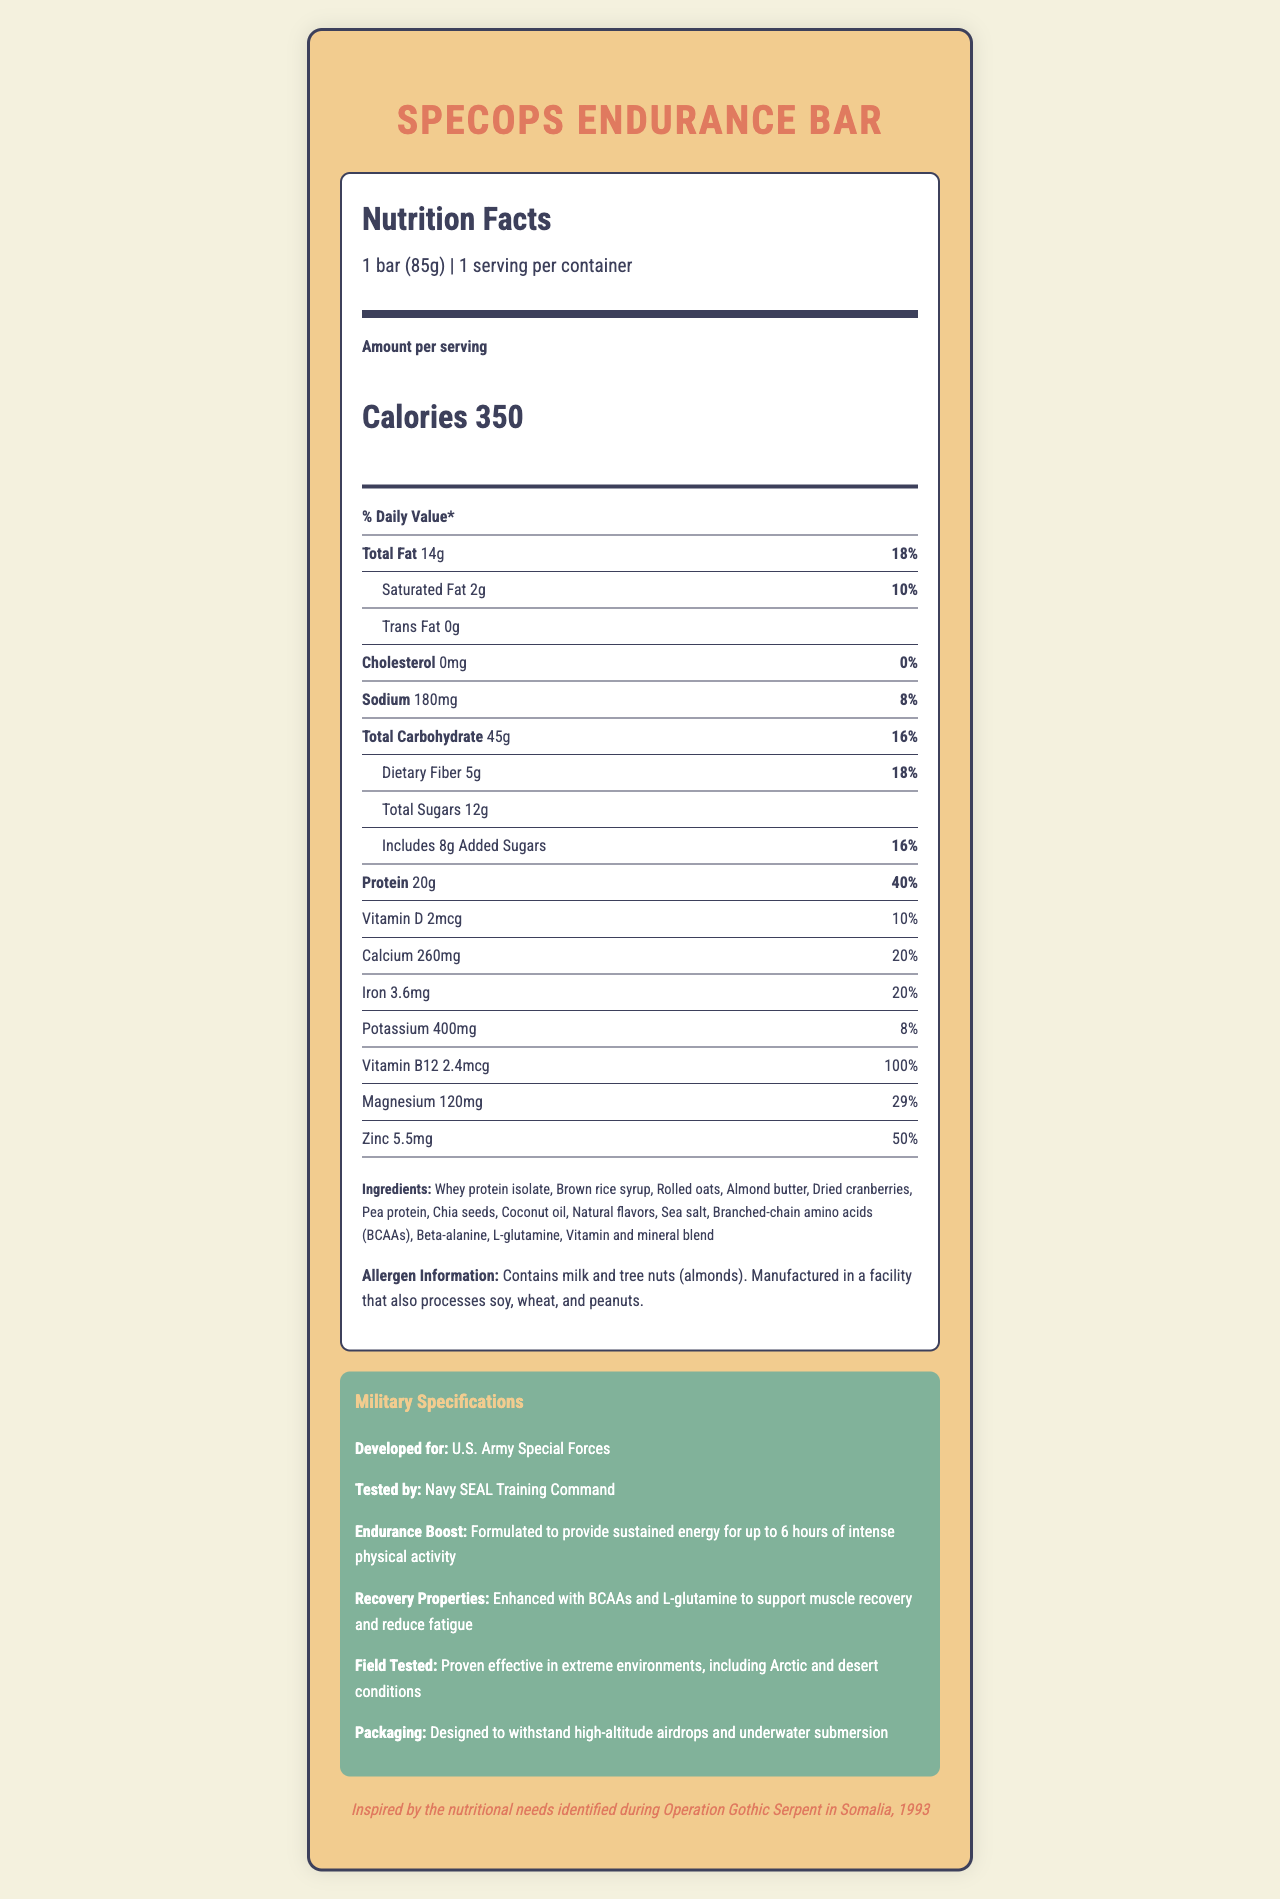what is the serving size? The serving size is specified as "1 bar (85g)" in the nutrition facts section.
Answer: 1 bar (85g) how many calories are there per serving? The document states that there are 350 calories per serving.
Answer: 350 how much protein does the SpecOps Endurance Bar contain per serving? The nutrition facts label lists 20g of protein per serving.
Answer: 20g what is the percentage daily value of magnesium? According to the document, magnesium has a daily value of 29%.
Answer: 29% which allergen is contained in the bar? The allergen information in the document lists milk and tree nuts (almonds) as allergens.
Answer: Milk and tree nuts (almonds) what is the main source of protein in the SpecOps Endurance Bar? The ingredients list mentions whey protein isolate and pea protein among the ingredients.
Answer: Whey protein isolate and pea protein what special ingredient is mentioned for muscle recovery? The military specifications section states that the bar contains BCAAs and L-glutamine to support muscle recovery and reduce fatigue.
Answer: Branched-chain amino acids (BCAAs) and L-glutamine how long can the SpecOps Endurance Bar provide sustained energy? The endurance boost information indicates that the bar is formulated to provide sustained energy for up to 6 hours of intense physical activity.
Answer: Up to 6 hours where was the SpecOps Endurance Bar tested? The military specifications section notes that the bar was tested by the Navy SEAL Training Command.
Answer: Navy SEAL Training Command what inspired the development of this nutrition bar? The historical context mentions that the development was inspired by nutritional needs identified during Operation Gothic Serpent in Somalia, 1993.
Answer: The nutritional needs identified during Operation Gothic Serpent in Somalia, 1993 which ingredient is NOT listed in the bar? A. Almond butter B. Peanut butter C. Coconut oil The ingredients list does not include "peanut butter," but it includes "almond butter" and "coconut oil."
Answer: B which vitamin has a daily value of 100%? A. Vitamin D B. Vitamin B12 C. Calcium D. Iron Vitamin B12 has a daily value of 100%, as listed in the nutrition facts.
Answer: B does the SpecOps Endurance Bar contain trans fat? The nutrition facts label indicates "0g" of trans fat.
Answer: No summarize the main idea of the document. The document describes the nutritional properties, ingredients, allergen information, military-specific features, testing, and historical background of the SpecOps Endurance Bar.
Answer: The document provides detailed nutritional information about the SpecOps Endurance Bar, developed for elite military units, outlining its calorie content, macronutrient levels, vitamins, and minerals. It also highlights its endurance and recovery properties, military testing, and historical inspiration. where was the SpecOps Endurance Bar manufactured? The document does not provide information about the manufacturing location of the SpecOps Endurance Bar.
Answer: Cannot be determined 